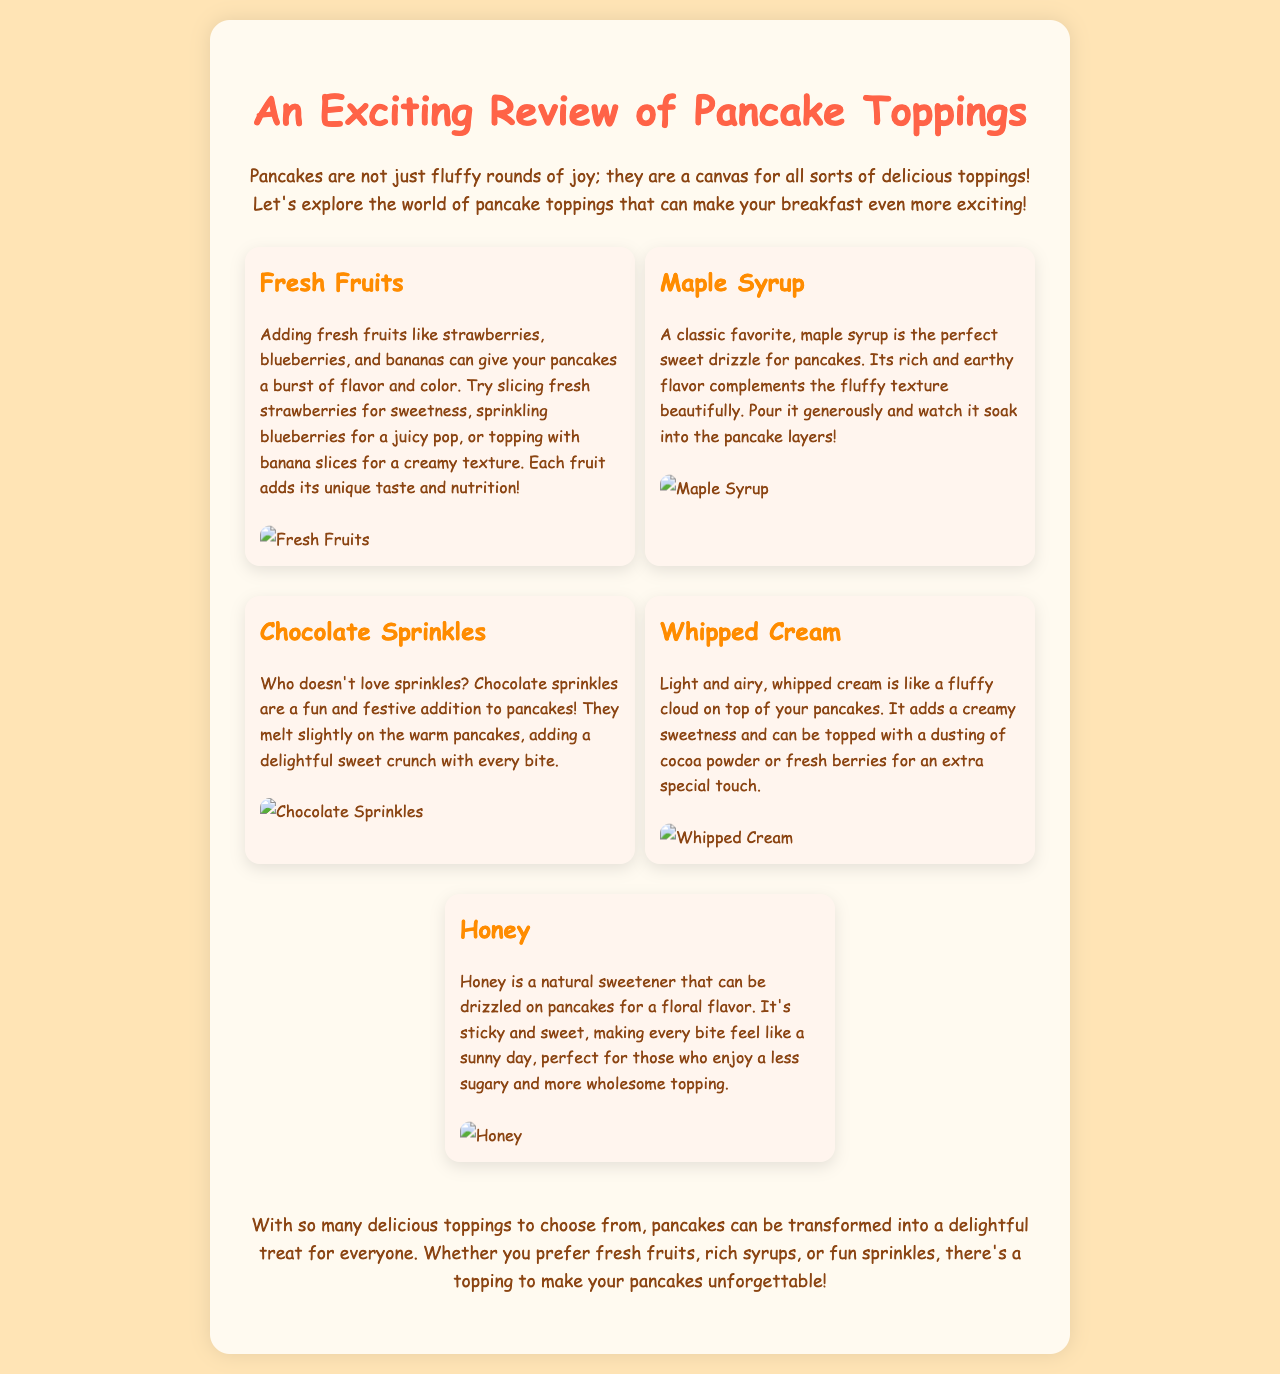What are the fruits mentioned as pancake toppings? The document lists fresh fruits such as strawberries, blueberries, and bananas as pancake toppings.
Answer: strawberries, blueberries, bananas What is a classic favorite topping for pancakes? The document identifies maple syrup as a classic favorite topping for pancakes.
Answer: maple syrup What do chocolate sprinkles add to pancakes? The document states that chocolate sprinkles add a delightful sweet crunch to pancakes.
Answer: sweet crunch Which topping is described as "like a fluffy cloud"? The document describes whipped cream as "like a fluffy cloud" on top of pancakes.
Answer: whipped cream What natural sweetener can be drizzled on pancakes? The document mentions honey as a natural sweetener that can be drizzled on pancakes.
Answer: honey What is the overall theme of the document? The document explores various delicious toppings for pancakes to make breakfast more exciting.
Answer: pancake toppings How do fresh fruits enhance pancakes? The document explains that fresh fruits give pancakes a burst of flavor and color.
Answer: flavor and color Which topping can be dusted with cocoa powder for an extra special touch? The document states that whipped cream can be topped with a dusting of cocoa powder for an extra special touch.
Answer: whipped cream 